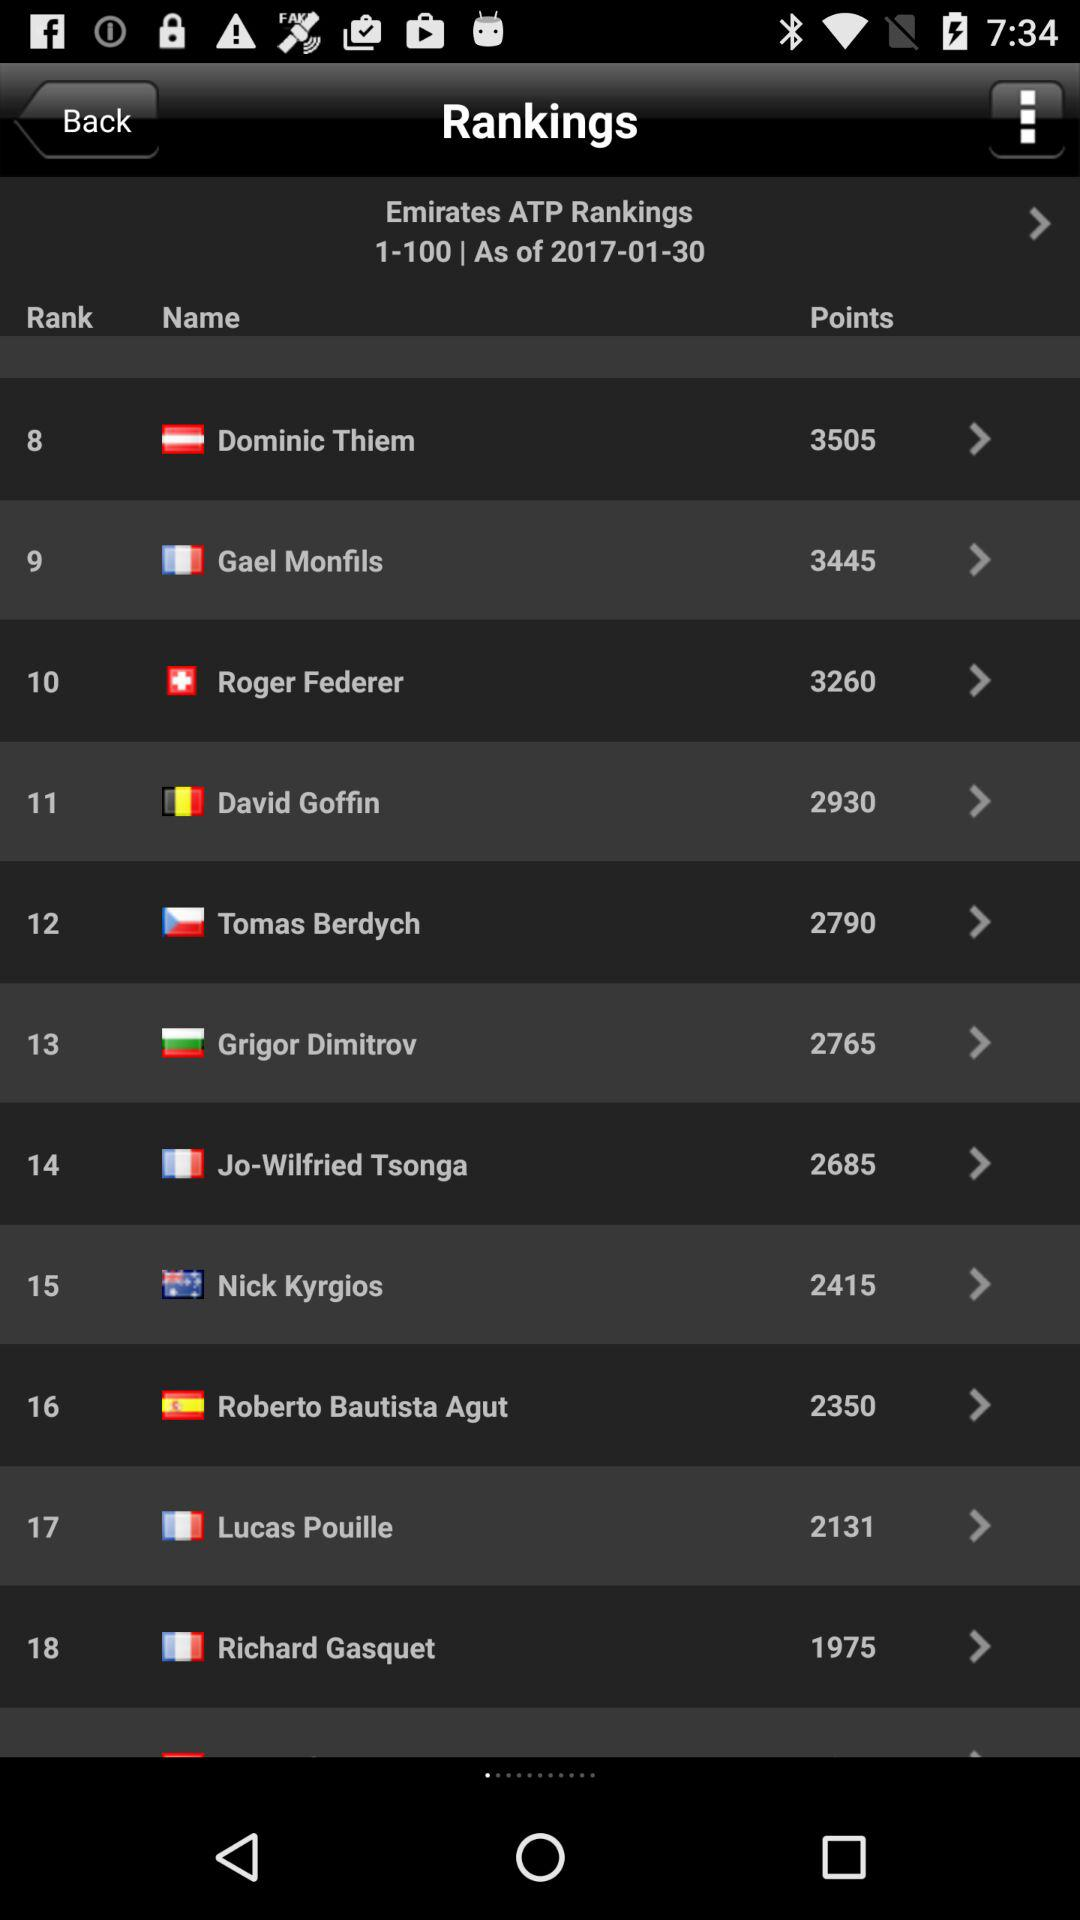How many points does Roger Federer have? Roger Federer has 3260 points. 